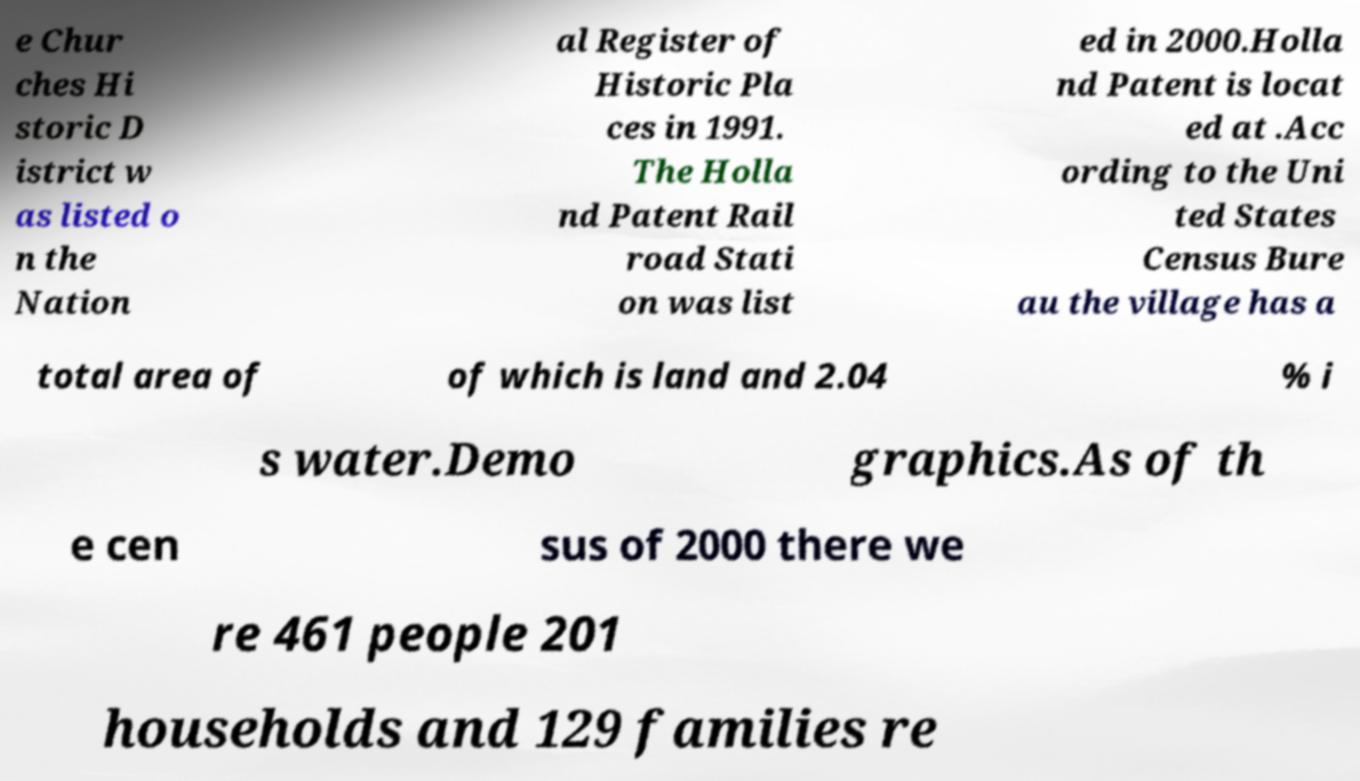Please read and relay the text visible in this image. What does it say? e Chur ches Hi storic D istrict w as listed o n the Nation al Register of Historic Pla ces in 1991. The Holla nd Patent Rail road Stati on was list ed in 2000.Holla nd Patent is locat ed at .Acc ording to the Uni ted States Census Bure au the village has a total area of of which is land and 2.04 % i s water.Demo graphics.As of th e cen sus of 2000 there we re 461 people 201 households and 129 families re 